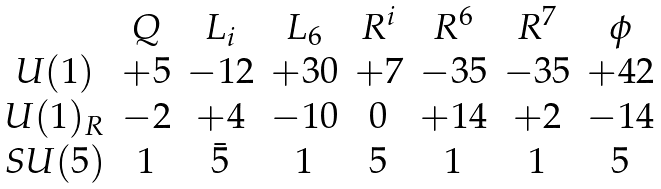<formula> <loc_0><loc_0><loc_500><loc_500>\begin{array} { c c c c c c c c } & Q & L _ { i } & L _ { 6 } & R ^ { i } & R ^ { 6 } & R ^ { 7 } & \phi \\ U ( 1 ) & + 5 & - 1 2 & + 3 0 & + 7 & - 3 5 & - 3 5 & + 4 2 \\ U ( 1 ) _ { R } & - 2 & + 4 & - 1 0 & 0 & + 1 4 & + 2 & - 1 4 \\ S U ( 5 ) & 1 & { \bar { 5 } } & 1 & { 5 } & 1 & 1 & { 5 } \end{array}</formula> 